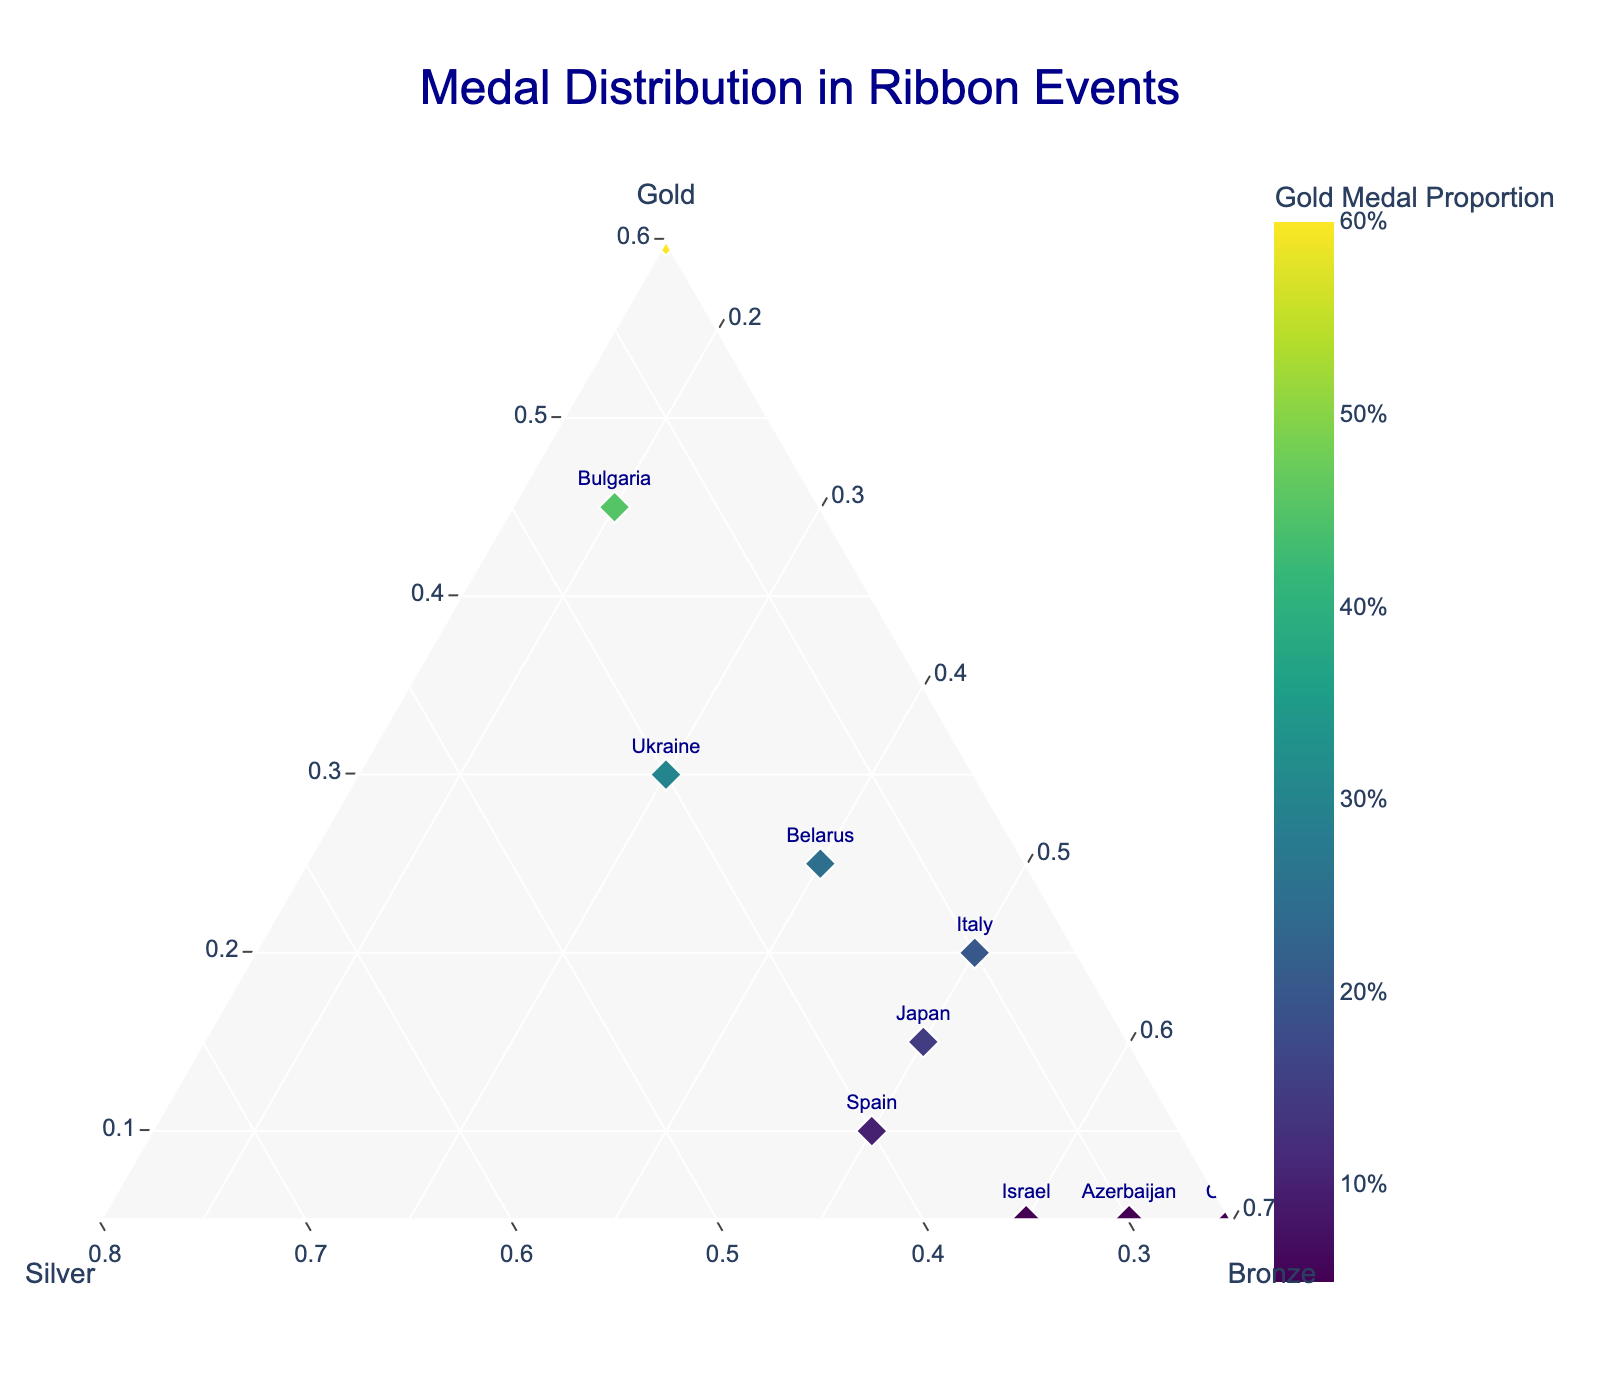What's the title of the plot? The title is centrally located at the top of the plot and reads "Medal Distribution in Ribbon Events".
Answer: Medal Distribution in Ribbon Events How is the color of the markers determined in the plot? The color of the markers is determined by the proportion of gold medals each country has won. The scale is indicated by a colorbar titled "Gold Medal Proportion".
Answer: Proportion of gold medals Which country has the highest proportion of bronze medals? By locating the country closest to the "Bronze" axis, we can see that China has the highest proportion of bronze medals.
Answer: China Which two countries have the same lowest proportion of gold medals? The plot shows both Israel and Azerbaijan located at the same position for the lowest proportion of gold medals along the "Gold" axis.
Answer: Israel and Azerbaijan What are the axis titles in the ternary plot? The ternary plot has three axis titles, which are "Gold" for the "a" axis, "Silver" for the "b" axis, and "Bronze" for the "c" axis.
Answer: Gold, Silver, Bronze Which country has the highest proportion of silver medals? By identifying the country closest to the "Silver" axis, we see that Ukraine has the highest proportion of silver medals.
Answer: Ukraine Which countries have a higher proportion of bronze medals than silver medals? By comparing the positions relative to the "Silver" and "Bronze" axes, we can see that Israel, Azerbaijan, and China have a higher proportion of bronze medals than silver medals.
Answer: Israel, Azerbaijan, China How many countries have a higher proportion of silver medals than gold medals? By counting the number of countries positioned closer to the "Silver" axis than the "Gold" axis, there are 9 countries that fit this criterion.
Answer: 9 What's the second-highest proportion of gold medals and which country has it? By finding the country next closest to the "Gold" axis after Russia, Bulgaria has the second-highest proportion of gold medals at 0.45.
Answer: Bulgaria Which countries have a higher proportion of gold medals than bronze medals? By comparing the countries' positions relative to the "Gold" and "Bronze" axes, Russia, Bulgaria, and Ukraine have a higher proportion of gold medals than bronze medals.
Answer: Russia, Bulgaria, Ukraine 